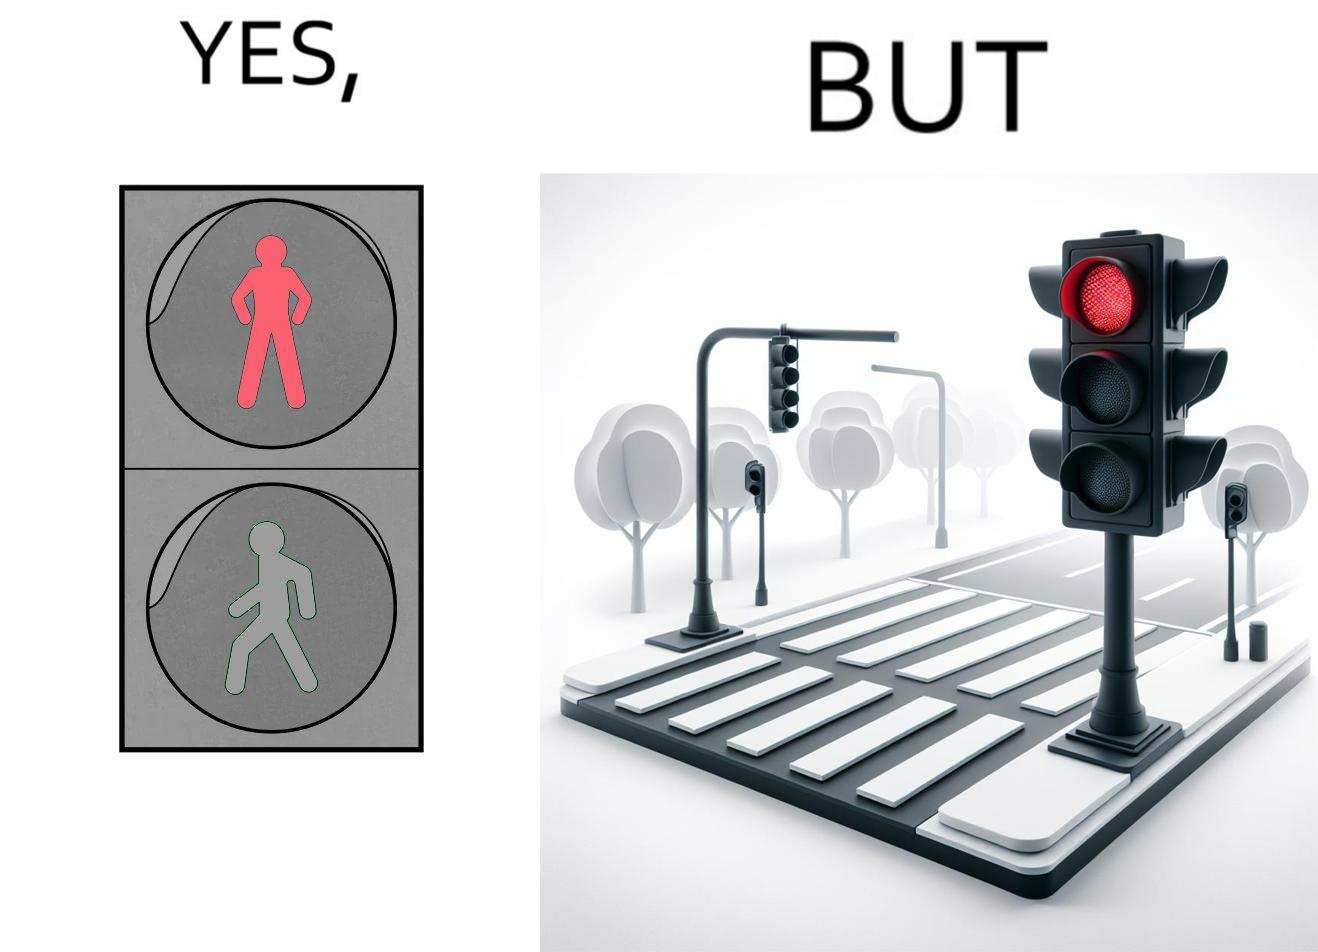Describe the satirical element in this image. The image is funny, as the traffic light for pedestrains is red, even though it is at a zebra crossing, which does not need a red light for stopping a pedestrain from crossing. Also, there are no people or vehicles around, which makes the image even funnier. 